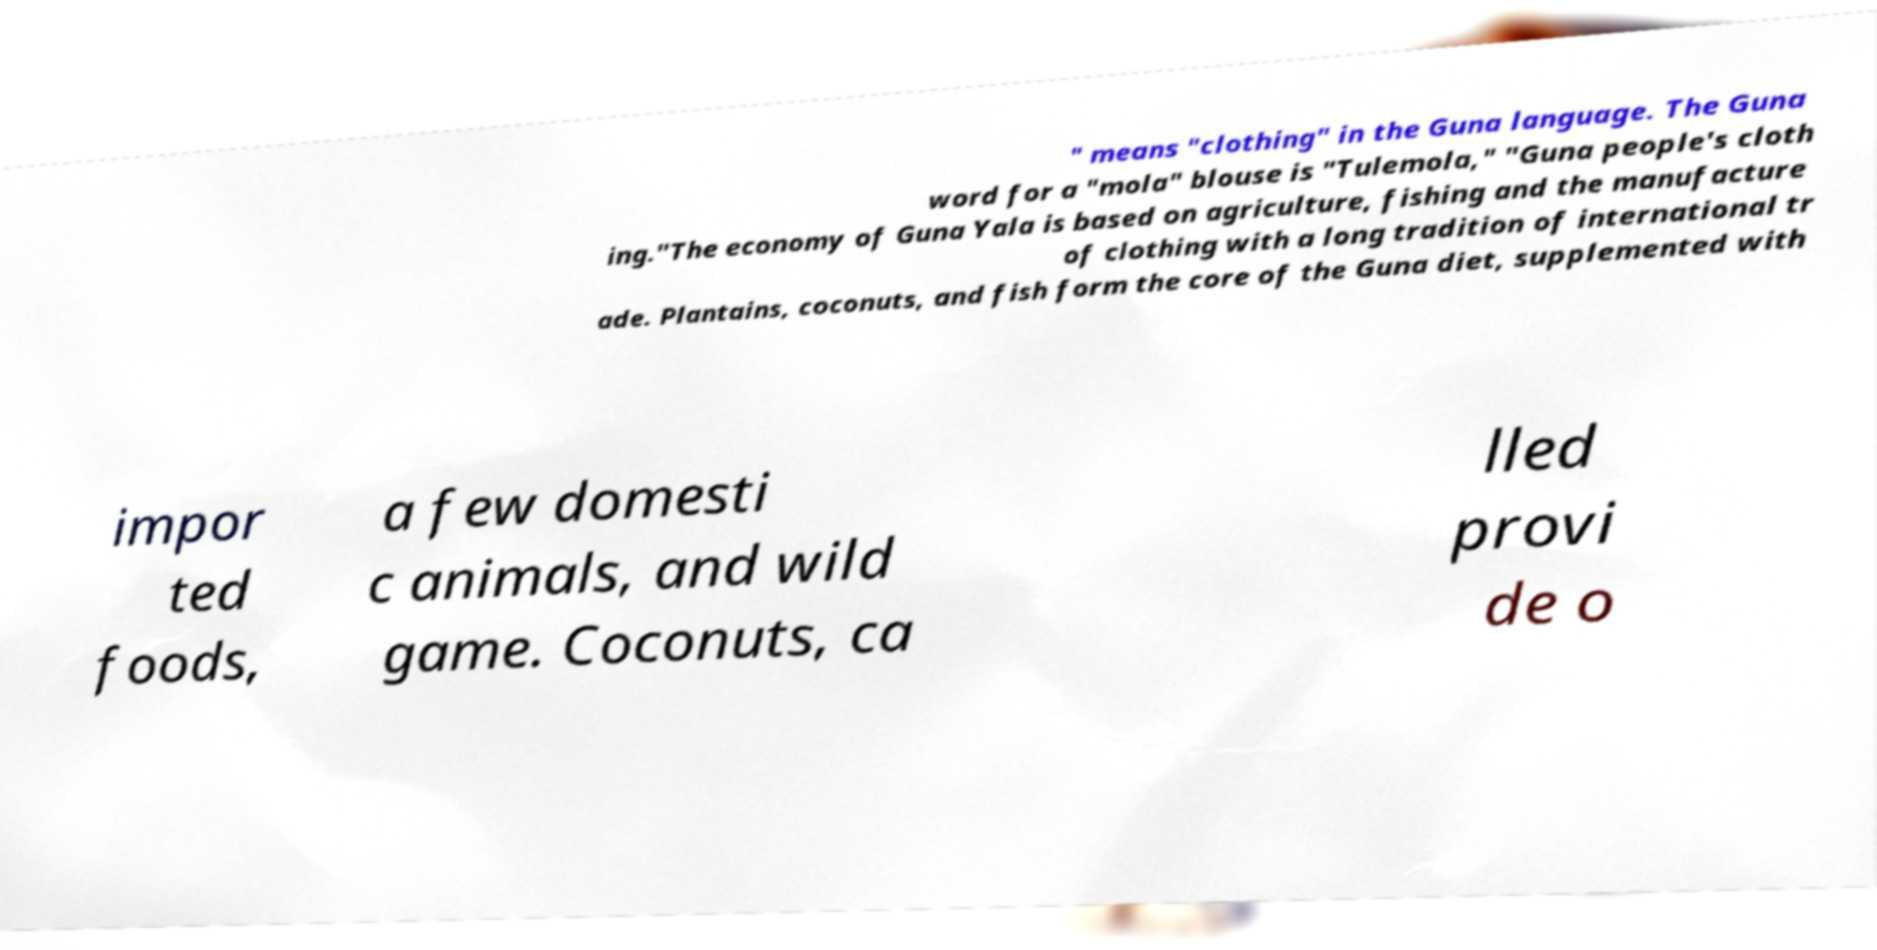For documentation purposes, I need the text within this image transcribed. Could you provide that? " means "clothing" in the Guna language. The Guna word for a "mola" blouse is "Tulemola," "Guna people's cloth ing."The economy of Guna Yala is based on agriculture, fishing and the manufacture of clothing with a long tradition of international tr ade. Plantains, coconuts, and fish form the core of the Guna diet, supplemented with impor ted foods, a few domesti c animals, and wild game. Coconuts, ca lled provi de o 